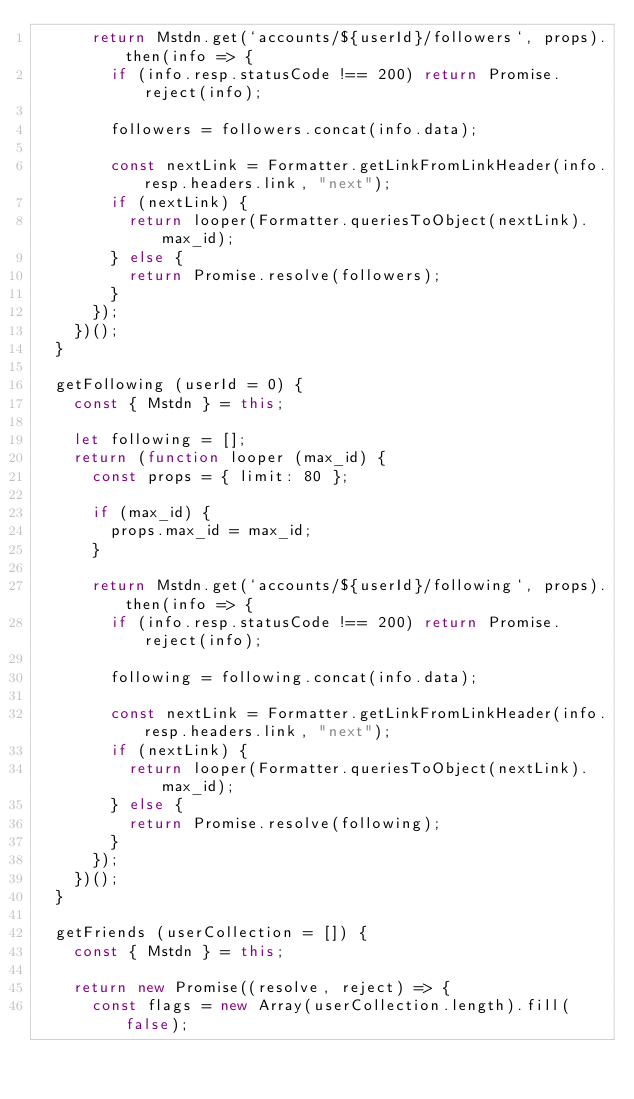<code> <loc_0><loc_0><loc_500><loc_500><_JavaScript_>			return Mstdn.get(`accounts/${userId}/followers`, props).then(info => {
				if (info.resp.statusCode !== 200) return Promise.reject(info);
				
				followers = followers.concat(info.data);

				const nextLink = Formatter.getLinkFromLinkHeader(info.resp.headers.link, "next");
				if (nextLink) {
					return looper(Formatter.queriesToObject(nextLink).max_id);
				} else {
					return Promise.resolve(followers);
				}
			});
		})();
	}

	getFollowing (userId = 0) {
		const { Mstdn } = this;

		let following = [];
		return (function looper (max_id) {
			const props = { limit: 80 };

			if (max_id) {
				props.max_id = max_id;
			}

			return Mstdn.get(`accounts/${userId}/following`, props).then(info => {
				if (info.resp.statusCode !== 200) return Promise.reject(info);

				following = following.concat(info.data);

				const nextLink = Formatter.getLinkFromLinkHeader(info.resp.headers.link, "next");
				if (nextLink) {
					return looper(Formatter.queriesToObject(nextLink).max_id);
				} else {
					return Promise.resolve(following);
				}
			});
		})();
	}

	getFriends (userCollection = []) {
		const { Mstdn } = this;

		return new Promise((resolve, reject) => {
			const flags = new Array(userCollection.length).fill(false);</code> 